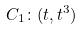Convert formula to latex. <formula><loc_0><loc_0><loc_500><loc_500>C _ { 1 } \colon ( t , t ^ { 3 } )</formula> 